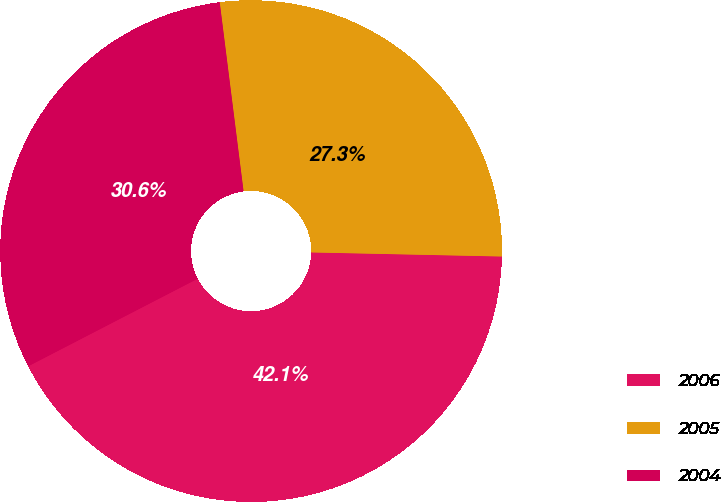Convert chart. <chart><loc_0><loc_0><loc_500><loc_500><pie_chart><fcel>2006<fcel>2005<fcel>2004<nl><fcel>42.07%<fcel>27.34%<fcel>30.59%<nl></chart> 